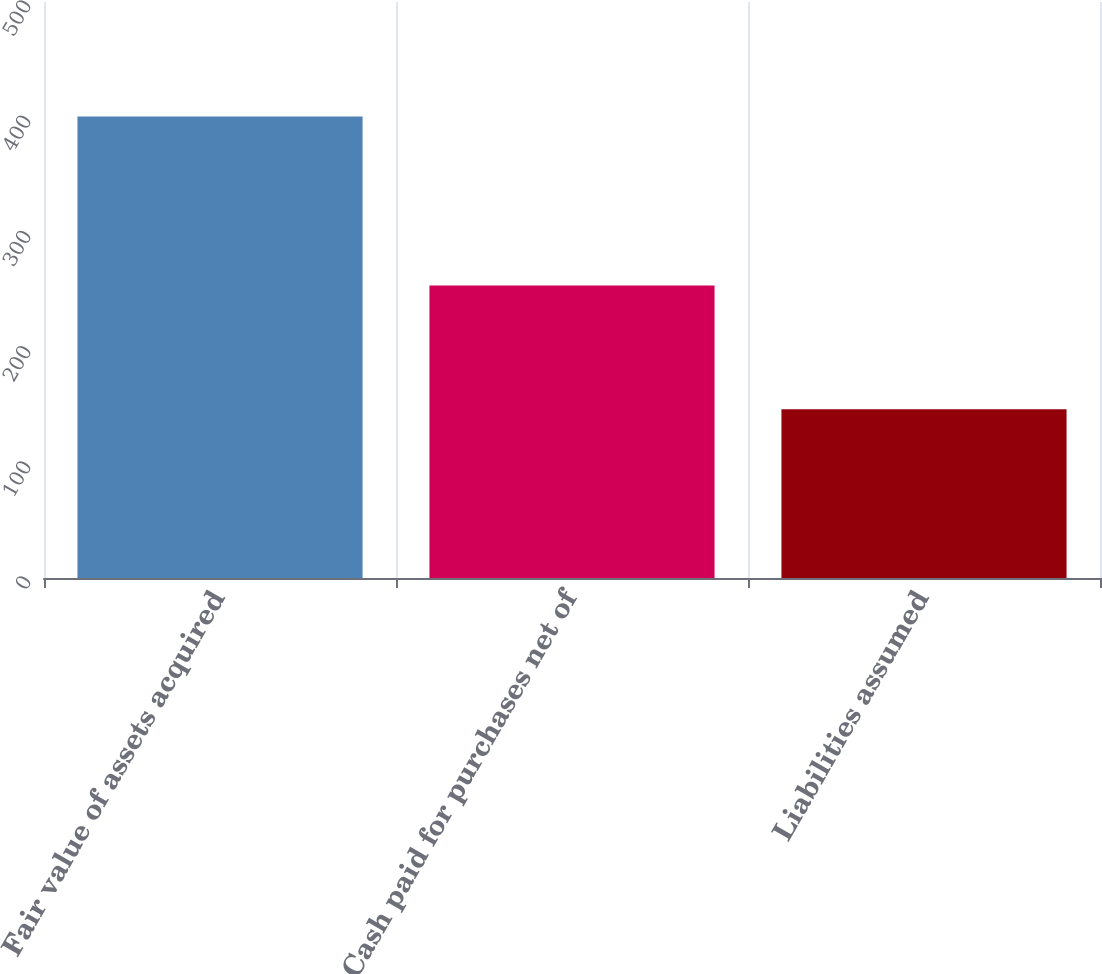Convert chart to OTSL. <chart><loc_0><loc_0><loc_500><loc_500><bar_chart><fcel>Fair value of assets acquired<fcel>Cash paid for purchases net of<fcel>Liabilities assumed<nl><fcel>400.5<fcel>254<fcel>146.5<nl></chart> 